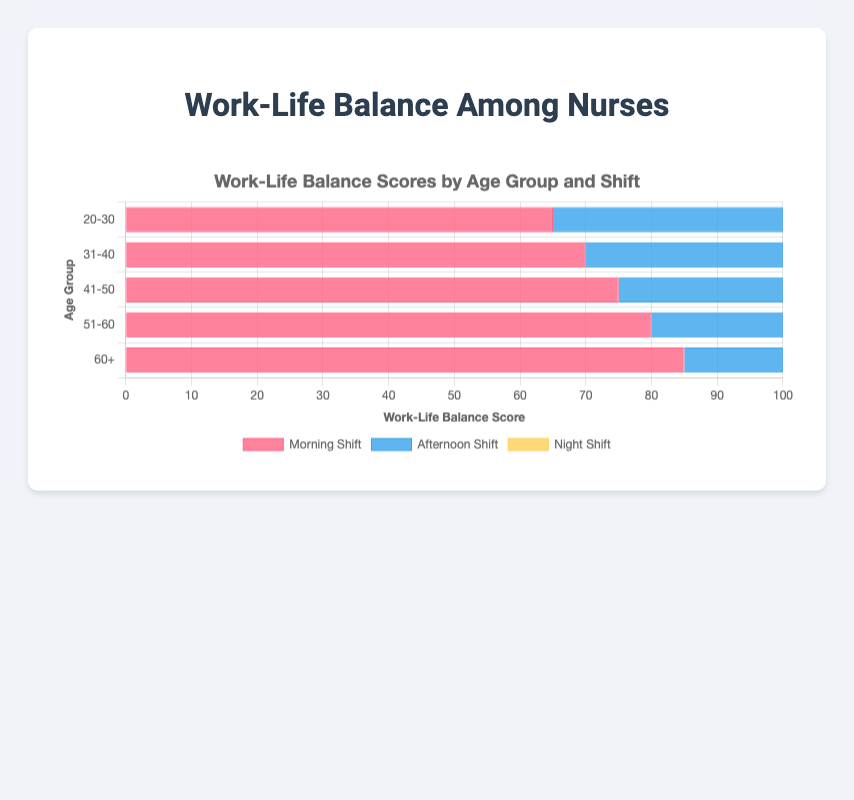What age group has the highest work-life balance score in the morning shift? The highest work-life balance score in the morning shift is 85, which is in the 60+ age group, as seen in the longest blue bar at the top of this section.
Answer: 60+ How does the work-life balance score in the afternoon shift for the 31-40 age group compare to the night shift for the same age group? In the afternoon shift, the 31-40 age group has a score of 65, and in the night shift, the score is 60. By comparing, it is clear 65 is greater than 60.
Answer: 65 is greater than 60 Which shift has the lowest average work-life balance score across all age groups? Sum the scores for each shift across all age groups and find the averages. Morning shift: (65+70+75+80+85)/5 = 75, Afternoon shift: (60+65+68+72+75)/5 = 68, Night shift: (55+60+65+70+74)/5 = 64. The night shift has the lowest average score at 64.
Answer: Night Shift What is the difference in work-life balance scores between the youngest (20-30) and oldest (60+) age groups for the morning shift? The score for 20-30 age group in the morning shift is 65 and for the 60+ age group is 85. The difference is calculated as 85 - 65 = 20.
Answer: 20 Which age group shows a consistent increase in work-life balance scores across all shifts? By examining the bars, we can see scores increase consistently across Morning, Afternoon, and Night shifts for the 60+ age group: 85, 75, and 74 respectively.
Answer: 60+ What are the visual colors used for each shift? By observing the chart, we see that the Morning Shift is represented in red, the Afternoon Shift in blue, and the Night Shift in yellow.
Answer: Red, Blue, and Yellow Which shift shows the smallest increase in work-life balance scores from the 20-30 age group to the 31-40 age group? By calculating the increases: Morning shift: 70 - 65 = 5, Afternoon shift: 65 - 60 = 5, Night shift: 60 - 55 = 5. Each shift shows an identical increase of 5.
Answer: All shifts (identical increase) For the afternoon shift, what is the range of work-life balance scores across all age groups? The range is the difference between the highest and lowest values. Highest score: 75 (60+), Lowest score: 60 (20-30). Range: 75 - 60 = 15.
Answer: 15 Compare the total work-life balance scores for the morning shift and the night shift across all age groups. Sum the scores for each shift: Morning shift: 65+70+75+80+85 = 375, Night shift: 55+60+65+70+74 = 324.
Answer: Morning shift has a higher total score 